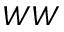Convert formula to latex. <formula><loc_0><loc_0><loc_500><loc_500>W W</formula> 